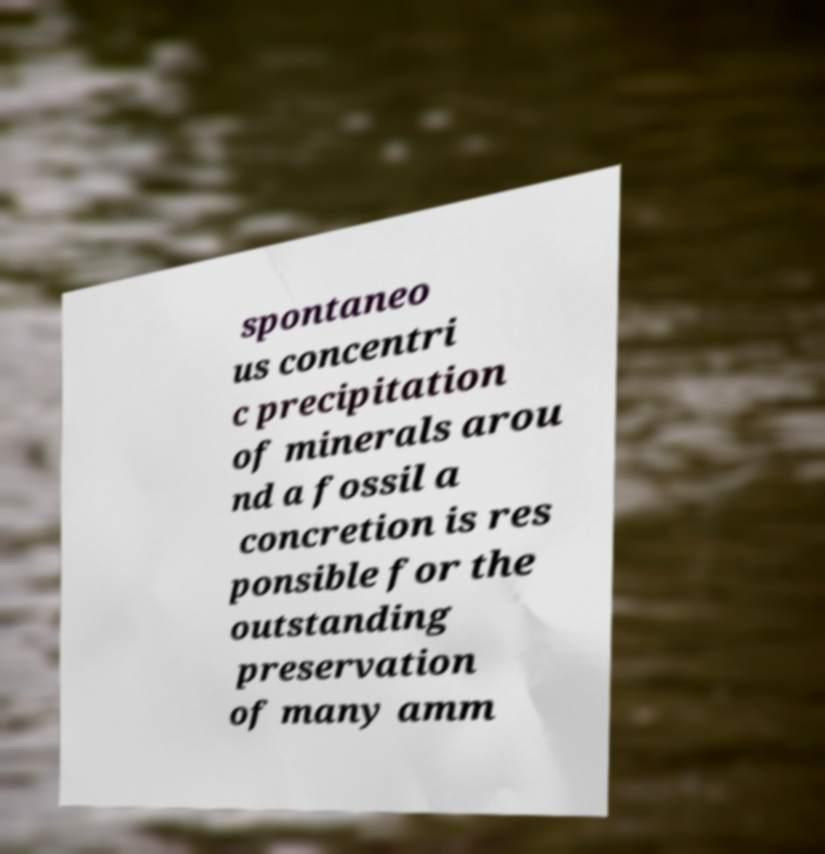What messages or text are displayed in this image? I need them in a readable, typed format. spontaneo us concentri c precipitation of minerals arou nd a fossil a concretion is res ponsible for the outstanding preservation of many amm 